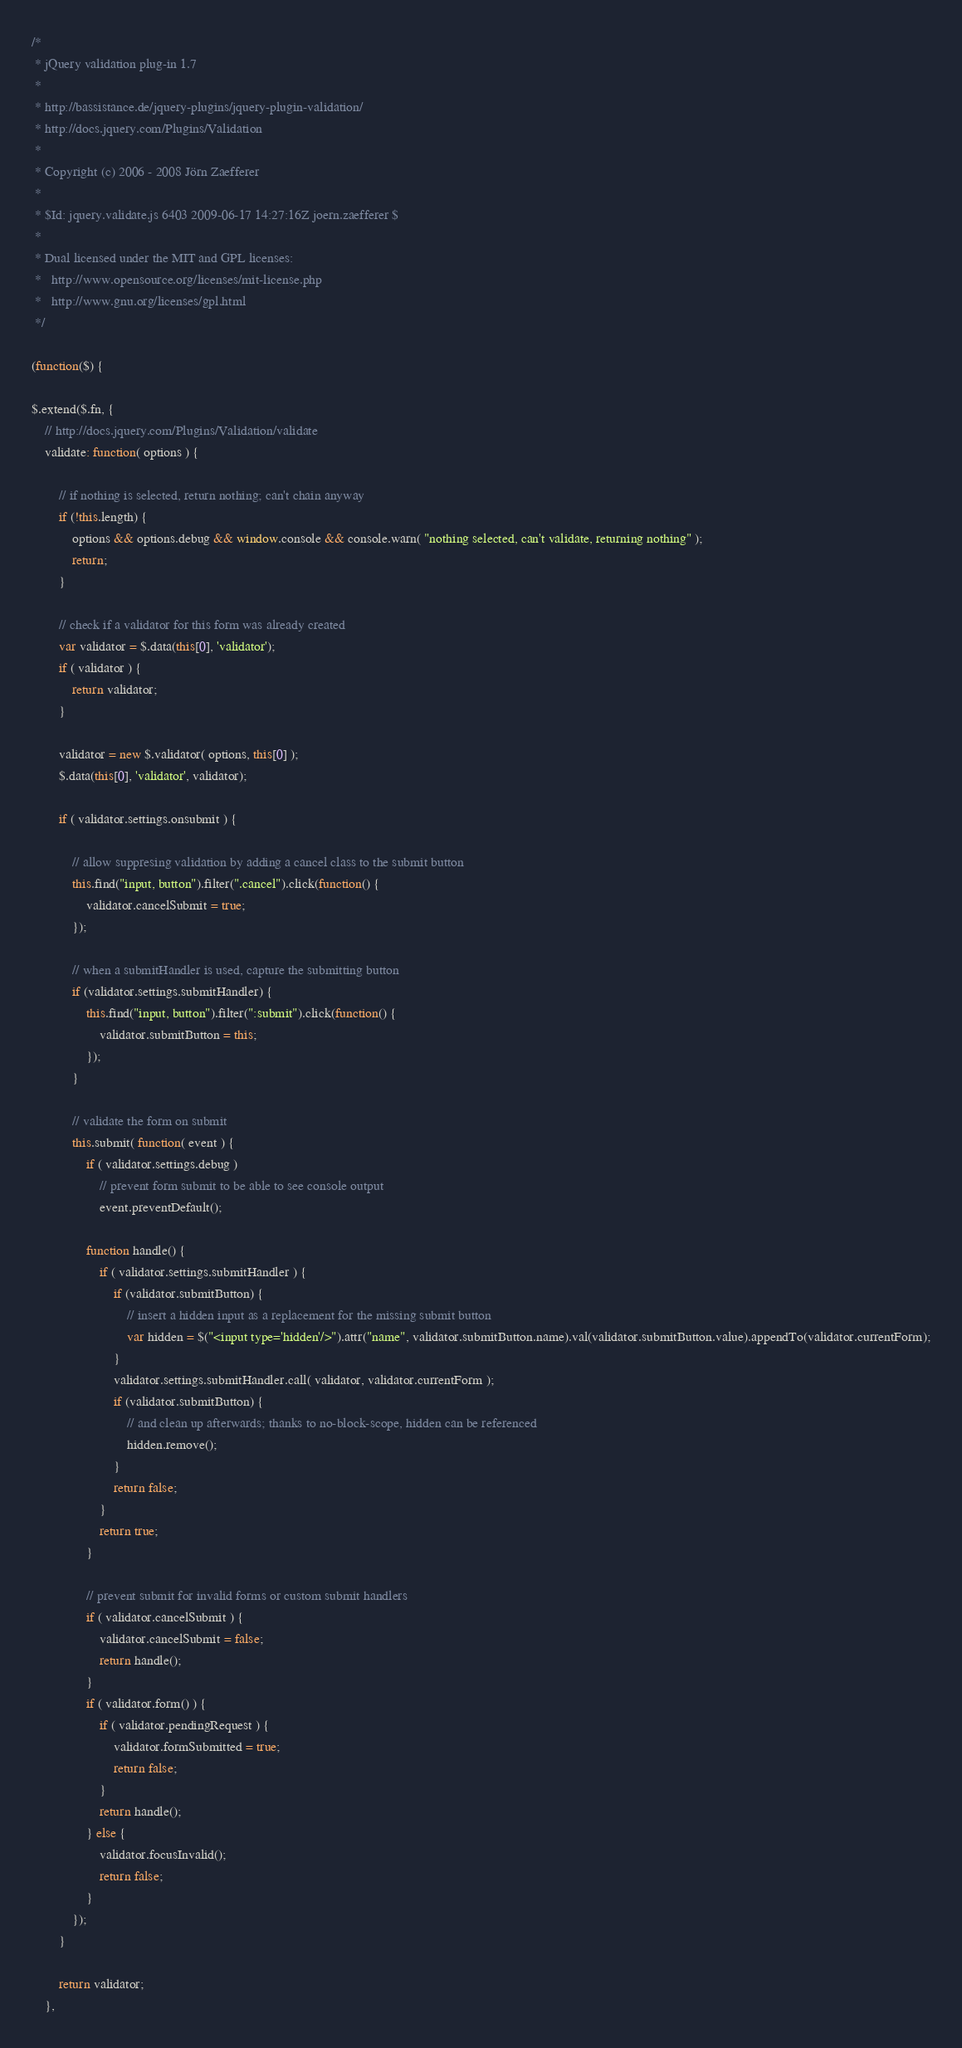Convert code to text. <code><loc_0><loc_0><loc_500><loc_500><_JavaScript_>/*
 * jQuery validation plug-in 1.7
 *
 * http://bassistance.de/jquery-plugins/jquery-plugin-validation/
 * http://docs.jquery.com/Plugins/Validation
 *
 * Copyright (c) 2006 - 2008 Jörn Zaefferer
 *
 * $Id: jquery.validate.js 6403 2009-06-17 14:27:16Z joern.zaefferer $
 *
 * Dual licensed under the MIT and GPL licenses:
 *   http://www.opensource.org/licenses/mit-license.php
 *   http://www.gnu.org/licenses/gpl.html
 */

(function($) {

$.extend($.fn, {
	// http://docs.jquery.com/Plugins/Validation/validate
	validate: function( options ) {

		// if nothing is selected, return nothing; can't chain anyway
		if (!this.length) {
			options && options.debug && window.console && console.warn( "nothing selected, can't validate, returning nothing" );
			return;
		}

		// check if a validator for this form was already created
		var validator = $.data(this[0], 'validator');
		if ( validator ) {
			return validator;
		}

		validator = new $.validator( options, this[0] );
		$.data(this[0], 'validator', validator);

		if ( validator.settings.onsubmit ) {

			// allow suppresing validation by adding a cancel class to the submit button
			this.find("input, button").filter(".cancel").click(function() {
				validator.cancelSubmit = true;
			});

			// when a submitHandler is used, capture the submitting button
			if (validator.settings.submitHandler) {
				this.find("input, button").filter(":submit").click(function() {
					validator.submitButton = this;
				});
			}

			// validate the form on submit
			this.submit( function( event ) {
				if ( validator.settings.debug )
					// prevent form submit to be able to see console output
					event.preventDefault();

				function handle() {
					if ( validator.settings.submitHandler ) {
						if (validator.submitButton) {
							// insert a hidden input as a replacement for the missing submit button
							var hidden = $("<input type='hidden'/>").attr("name", validator.submitButton.name).val(validator.submitButton.value).appendTo(validator.currentForm);
						}
						validator.settings.submitHandler.call( validator, validator.currentForm );
						if (validator.submitButton) {
							// and clean up afterwards; thanks to no-block-scope, hidden can be referenced
							hidden.remove();
						}
						return false;
					}
					return true;
				}

				// prevent submit for invalid forms or custom submit handlers
				if ( validator.cancelSubmit ) {
					validator.cancelSubmit = false;
					return handle();
				}
				if ( validator.form() ) {
					if ( validator.pendingRequest ) {
						validator.formSubmitted = true;
						return false;
					}
					return handle();
				} else {
					validator.focusInvalid();
					return false;
				}
			});
		}

		return validator;
	},</code> 